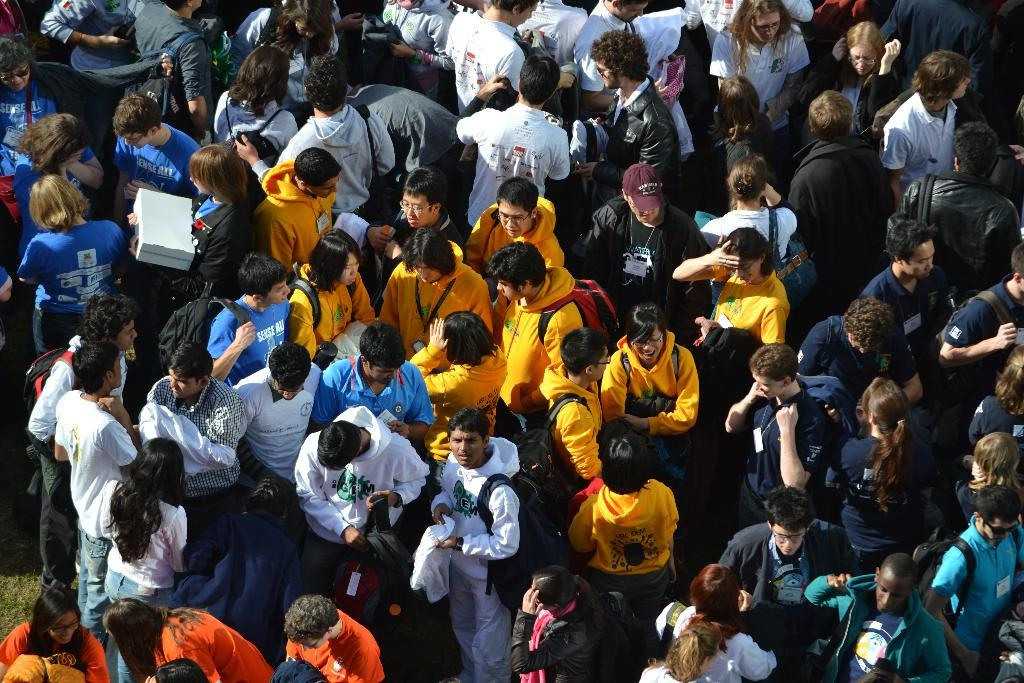What is happening in the foreground of the image? There are people standing in the foreground of the image. Can you describe what the people are wearing or carrying? Some of the people are wearing bags. What is the person on the left side of the image holding? A person is holding a box on the left side of the image. What type of store can be seen in the background of the image? There is no store visible in the image; it only shows people standing in the foreground. Can you tell me how many wings are present on the person holding the box? There are no wings present on the person holding the box in the image. 